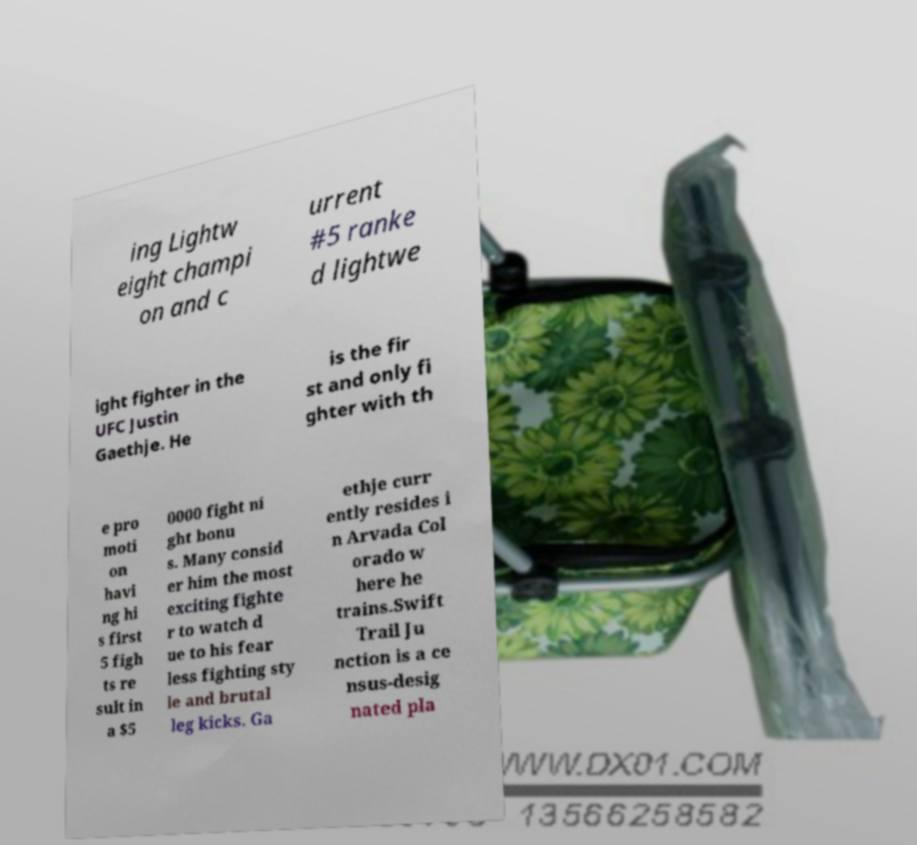Can you accurately transcribe the text from the provided image for me? ing Lightw eight champi on and c urrent #5 ranke d lightwe ight fighter in the UFC Justin Gaethje. He is the fir st and only fi ghter with th e pro moti on havi ng hi s first 5 figh ts re sult in a $5 0000 fight ni ght bonu s. Many consid er him the most exciting fighte r to watch d ue to his fear less fighting sty le and brutal leg kicks. Ga ethje curr ently resides i n Arvada Col orado w here he trains.Swift Trail Ju nction is a ce nsus-desig nated pla 